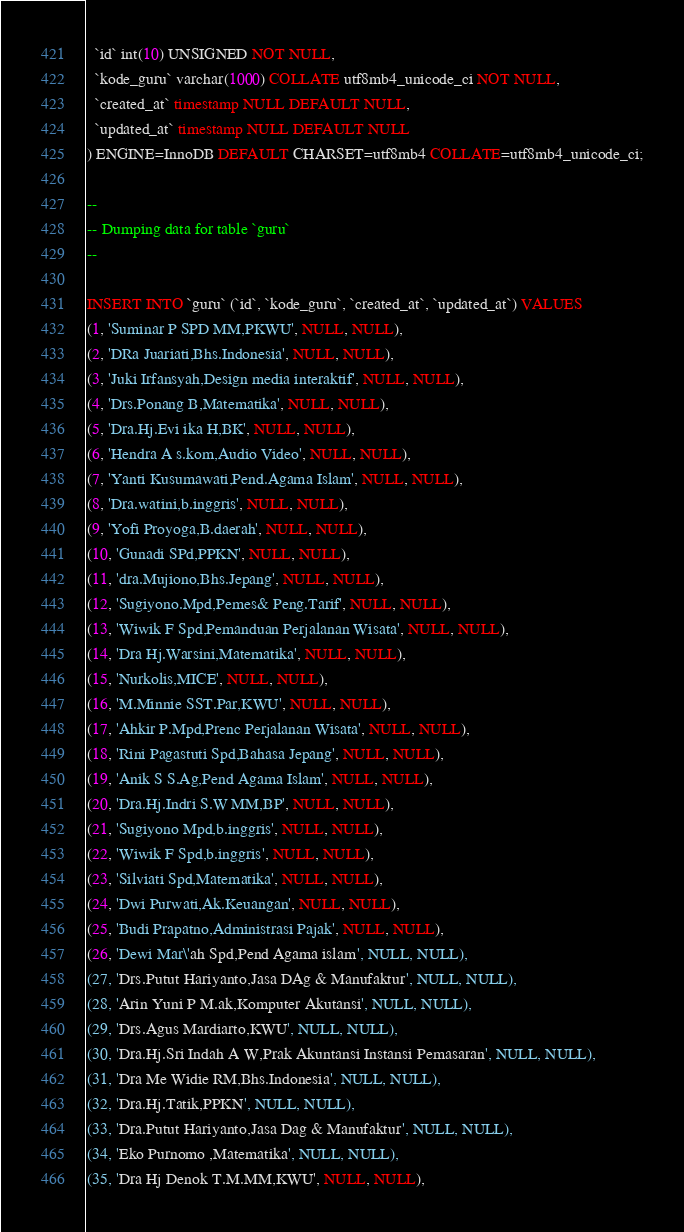<code> <loc_0><loc_0><loc_500><loc_500><_SQL_>  `id` int(10) UNSIGNED NOT NULL,
  `kode_guru` varchar(1000) COLLATE utf8mb4_unicode_ci NOT NULL,
  `created_at` timestamp NULL DEFAULT NULL,
  `updated_at` timestamp NULL DEFAULT NULL
) ENGINE=InnoDB DEFAULT CHARSET=utf8mb4 COLLATE=utf8mb4_unicode_ci;

--
-- Dumping data for table `guru`
--

INSERT INTO `guru` (`id`, `kode_guru`, `created_at`, `updated_at`) VALUES
(1, 'Suminar P SPD MM,PKWU', NULL, NULL),
(2, 'DRa Juariati,Bhs.Indonesia', NULL, NULL),
(3, 'Juki Irfansyah,Design media interaktif', NULL, NULL),
(4, 'Drs.Ponang B,Matematika', NULL, NULL),
(5, 'Dra.Hj.Evi ika H,BK', NULL, NULL),
(6, 'Hendra A s.kom,Audio Video', NULL, NULL),
(7, 'Yanti Kusumawati,Pend.Agama Islam', NULL, NULL),
(8, 'Dra.watini,b.inggris', NULL, NULL),
(9, 'Yofi Proyoga,B.daerah', NULL, NULL),
(10, 'Gunadi SPd,PPKN', NULL, NULL),
(11, 'dra.Mujiono,Bhs.Jepang', NULL, NULL),
(12, 'Sugiyono.Mpd,Pemes& Peng.Tarif', NULL, NULL),
(13, 'Wiwik F Spd,Pemanduan Perjalanan Wisata', NULL, NULL),
(14, 'Dra Hj.Warsini,Matematika', NULL, NULL),
(15, 'Nurkolis,MICE', NULL, NULL),
(16, 'M.Minnie SST.Par,KWU', NULL, NULL),
(17, 'Ahkir P.Mpd,Prenc Perjalanan Wisata', NULL, NULL),
(18, 'Rini Pagastuti Spd,Bahasa Jepang', NULL, NULL),
(19, 'Anik S S.Ag,Pend Agama Islam', NULL, NULL),
(20, 'Dra.Hj.Indri S.W MM,BP', NULL, NULL),
(21, 'Sugiyono Mpd,b.inggris', NULL, NULL),
(22, 'Wiwik F Spd,b.inggris', NULL, NULL),
(23, 'Silviati Spd,Matematika', NULL, NULL),
(24, 'Dwi Purwati,Ak.Keuangan', NULL, NULL),
(25, 'Budi Prapatno,Administrasi Pajak', NULL, NULL),
(26, 'Dewi Mar\'ah Spd,Pend Agama islam', NULL, NULL),
(27, 'Drs.Putut Hariyanto,Jasa DAg & Manufaktur', NULL, NULL),
(28, 'Arin Yuni P M.ak,Komputer Akutansi', NULL, NULL),
(29, 'Drs.Agus Mardiarto,KWU', NULL, NULL),
(30, 'Dra.Hj.Sri Indah A W,Prak Akuntansi Instansi Pemasaran', NULL, NULL),
(31, 'Dra Me Widie RM,Bhs.Indonesia', NULL, NULL),
(32, 'Dra.Hj.Tatik,PPKN', NULL, NULL),
(33, 'Dra.Putut Hariyanto,Jasa Dag & Manufaktur', NULL, NULL),
(34, 'Eko Purnomo ,Matematika', NULL, NULL),
(35, 'Dra Hj Denok T.M.MM,KWU', NULL, NULL),</code> 